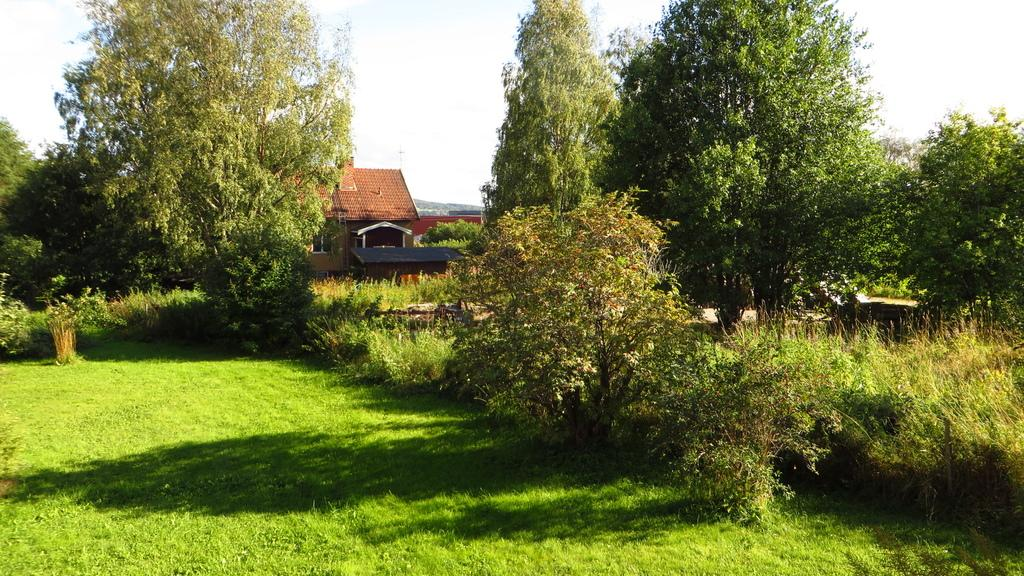What type of structure is visible in the picture? There is a house in the picture. What natural elements surround the house? There are trees and grass around the house. What type of insect can be seen crawling on the house in the picture? There is no insect visible on the house in the picture. What season is depicted in the picture, given the presence of trees and grass? The season cannot be determined from the presence of trees and grass alone, as these elements can be present in various seasons. 